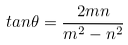<formula> <loc_0><loc_0><loc_500><loc_500>t a n \theta = \frac { 2 m n } { m ^ { 2 } - n ^ { 2 } }</formula> 